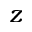<formula> <loc_0><loc_0><loc_500><loc_500>z</formula> 